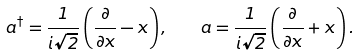Convert formula to latex. <formula><loc_0><loc_0><loc_500><loc_500>a ^ { \dagger } = \frac { 1 } { i \sqrt { 2 } } \left ( \frac { \partial } { \partial x } - x \right ) , \quad a = \frac { 1 } { i \sqrt { 2 } } \left ( \frac { \partial } { \partial x } + x \right ) .</formula> 